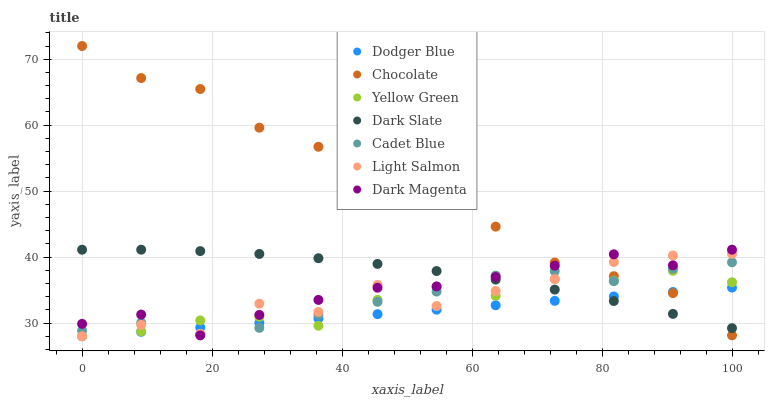Does Dodger Blue have the minimum area under the curve?
Answer yes or no. Yes. Does Chocolate have the maximum area under the curve?
Answer yes or no. Yes. Does Cadet Blue have the minimum area under the curve?
Answer yes or no. No. Does Cadet Blue have the maximum area under the curve?
Answer yes or no. No. Is Dodger Blue the smoothest?
Answer yes or no. Yes. Is Light Salmon the roughest?
Answer yes or no. Yes. Is Cadet Blue the smoothest?
Answer yes or no. No. Is Cadet Blue the roughest?
Answer yes or no. No. Does Light Salmon have the lowest value?
Answer yes or no. Yes. Does Cadet Blue have the lowest value?
Answer yes or no. No. Does Chocolate have the highest value?
Answer yes or no. Yes. Does Cadet Blue have the highest value?
Answer yes or no. No. Does Dark Slate intersect Cadet Blue?
Answer yes or no. Yes. Is Dark Slate less than Cadet Blue?
Answer yes or no. No. Is Dark Slate greater than Cadet Blue?
Answer yes or no. No. 